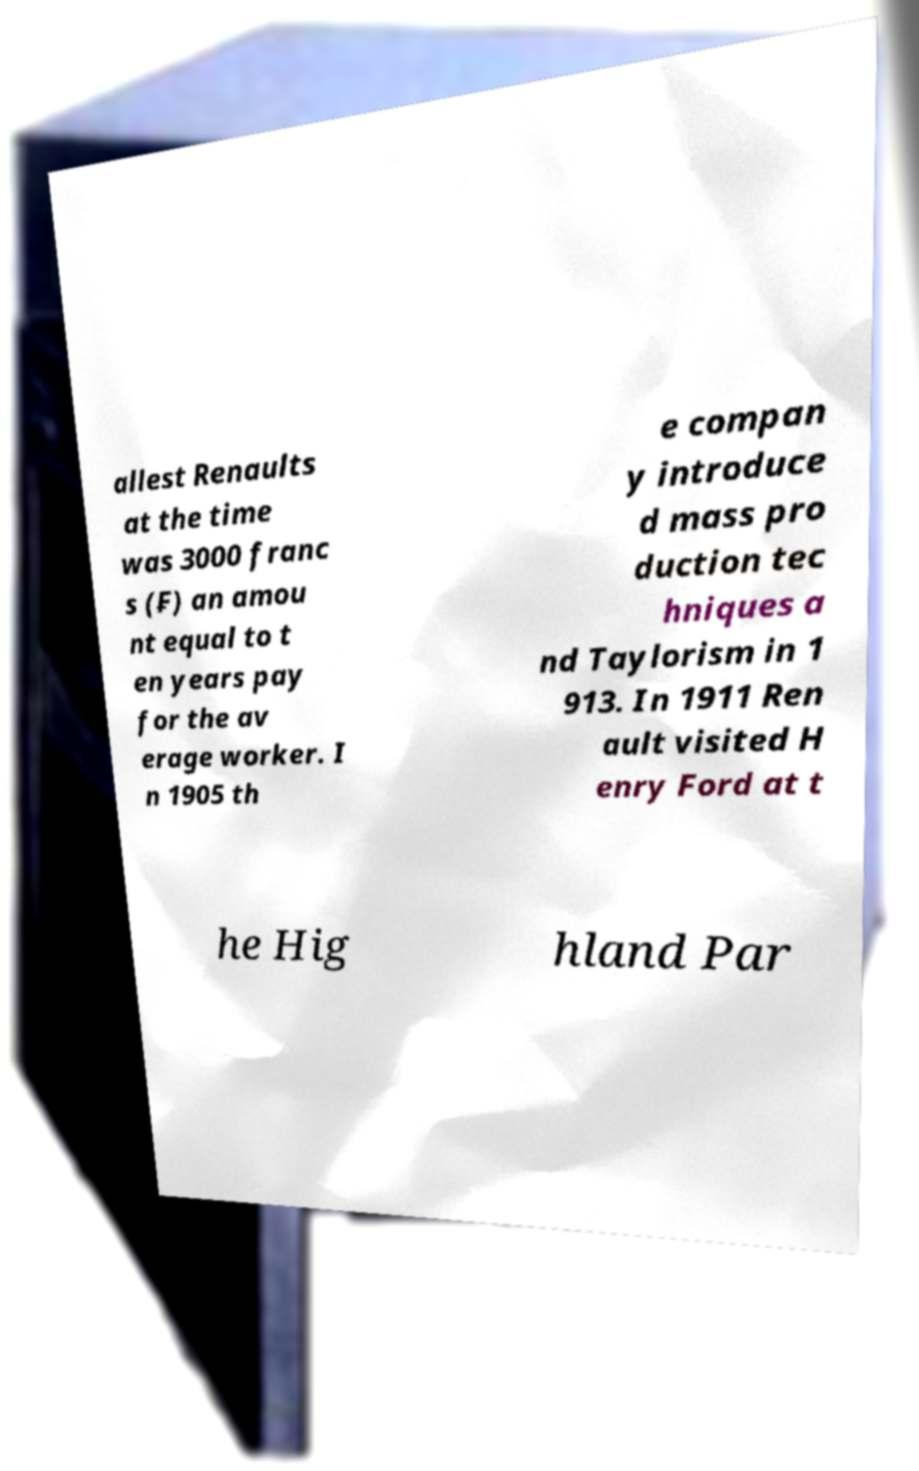Please identify and transcribe the text found in this image. allest Renaults at the time was 3000 franc s (₣) an amou nt equal to t en years pay for the av erage worker. I n 1905 th e compan y introduce d mass pro duction tec hniques a nd Taylorism in 1 913. In 1911 Ren ault visited H enry Ford at t he Hig hland Par 